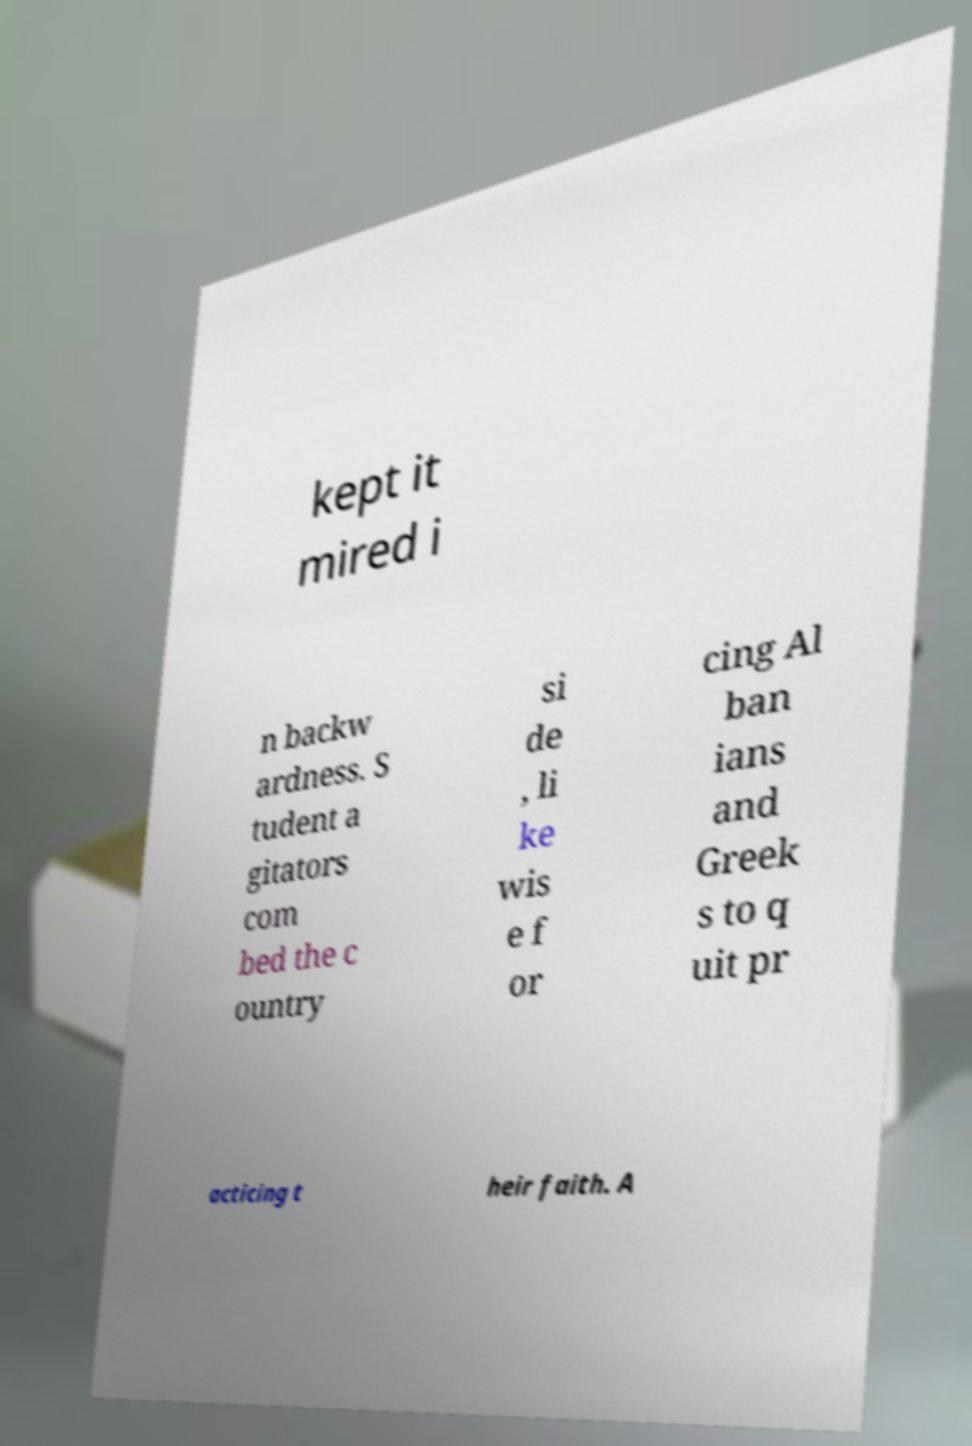I need the written content from this picture converted into text. Can you do that? kept it mired i n backw ardness. S tudent a gitators com bed the c ountry si de , li ke wis e f or cing Al ban ians and Greek s to q uit pr acticing t heir faith. A 